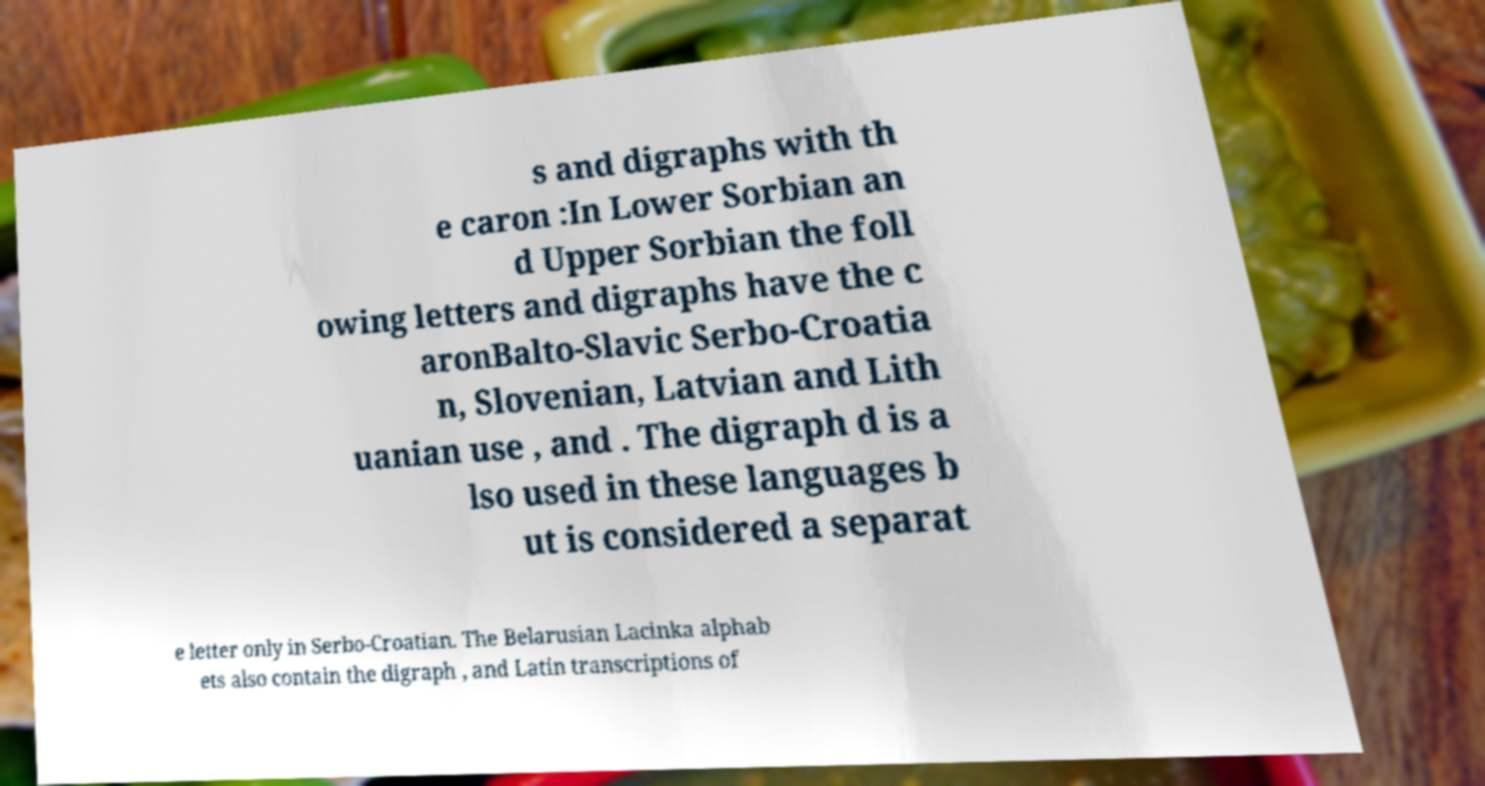Can you read and provide the text displayed in the image?This photo seems to have some interesting text. Can you extract and type it out for me? s and digraphs with th e caron :In Lower Sorbian an d Upper Sorbian the foll owing letters and digraphs have the c aronBalto-Slavic Serbo-Croatia n, Slovenian, Latvian and Lith uanian use , and . The digraph d is a lso used in these languages b ut is considered a separat e letter only in Serbo-Croatian. The Belarusian Lacinka alphab ets also contain the digraph , and Latin transcriptions of 